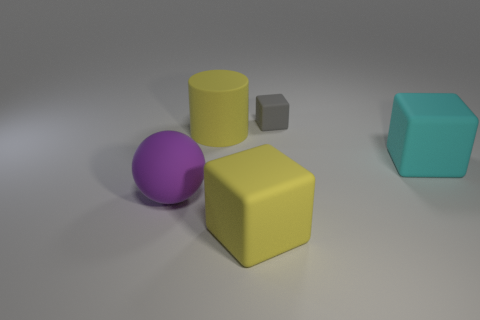There is a big yellow thing that is left of the big yellow rubber thing in front of the large purple object; what number of cylinders are to the right of it?
Offer a terse response. 0. Is the shape of the gray rubber object the same as the purple rubber thing?
Provide a short and direct response. No. Is there a cyan rubber thing of the same shape as the gray object?
Provide a short and direct response. Yes. The purple matte object that is the same size as the matte cylinder is what shape?
Your answer should be very brief. Sphere. There is a big yellow object to the left of the large block that is in front of the rubber cube that is to the right of the gray matte object; what is it made of?
Your answer should be very brief. Rubber. Is the gray thing the same size as the matte cylinder?
Offer a terse response. No. What is the material of the gray cube?
Provide a succinct answer. Rubber. What is the material of the big block that is the same color as the cylinder?
Your answer should be very brief. Rubber. There is a big rubber thing that is to the right of the tiny gray cube; is its shape the same as the gray thing?
Make the answer very short. Yes. What number of things are either big cyan matte objects or big gray metal things?
Provide a succinct answer. 1. 